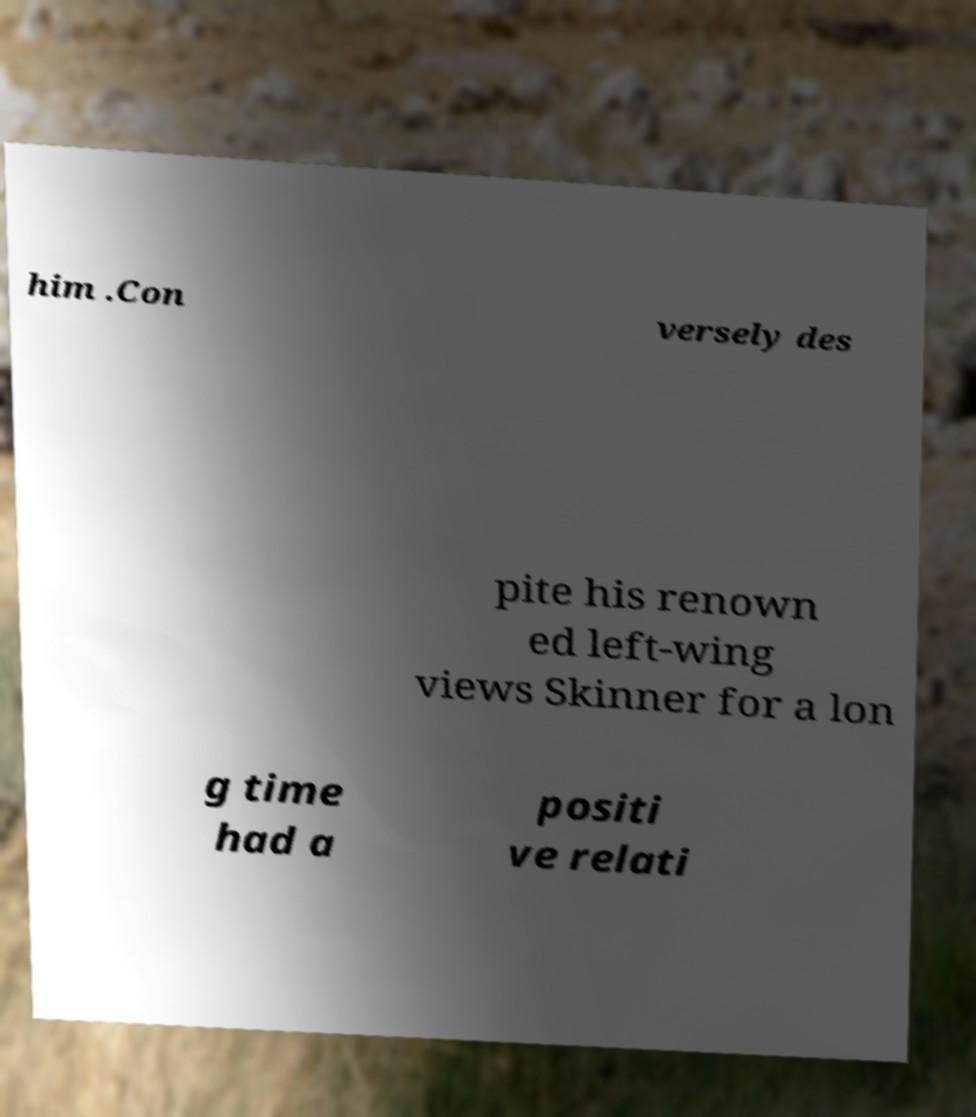Please read and relay the text visible in this image. What does it say? him .Con versely des pite his renown ed left-wing views Skinner for a lon g time had a positi ve relati 